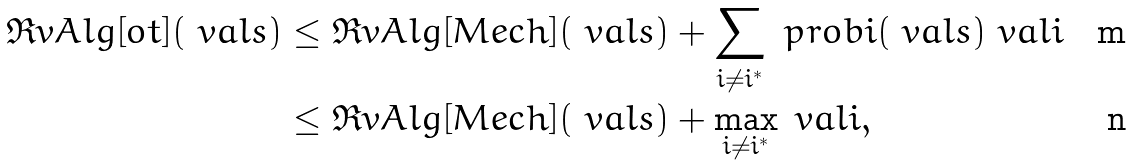<formula> <loc_0><loc_0><loc_500><loc_500>\Re v A l g [ \L o t ] ( \ v a l s ) & \leq \Re v A l g [ \L M e c h ] ( \ v a l s ) + \sum _ { i \neq i ^ { \ast } } \ p r o b i ( \ v a l s ) \ v a l i \\ & \leq \Re v A l g [ \L M e c h ] ( \ v a l s ) + \max _ { i \neq i ^ { \ast } } \ v a l i ,</formula> 